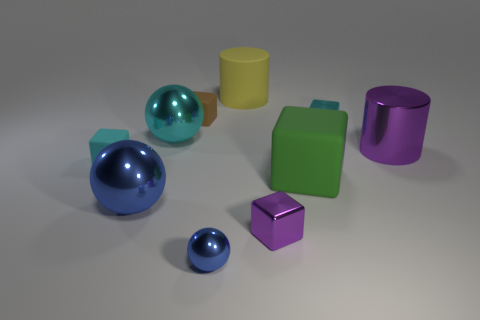Do the shiny cylinder and the metal cube in front of the large green cube have the same color?
Provide a succinct answer. Yes. What number of objects are either objects left of the small purple shiny thing or small blocks left of the tiny sphere?
Your answer should be compact. 6. There is a tiny cube that is to the left of the big green block and behind the metallic cylinder; what color is it?
Provide a short and direct response. Brown. Are there more big matte things than things?
Provide a succinct answer. No. Do the tiny shiny object right of the small purple shiny thing and the large purple metal object have the same shape?
Offer a terse response. No. What number of metallic objects are either tiny purple cubes or big cyan spheres?
Your answer should be very brief. 2. Is there a tiny purple thing made of the same material as the large purple thing?
Ensure brevity in your answer.  Yes. What is the yellow cylinder made of?
Offer a very short reply. Rubber. There is a blue object that is left of the blue metallic thing that is in front of the large ball that is in front of the green matte thing; what shape is it?
Provide a succinct answer. Sphere. Is the number of blue things in front of the tiny purple thing greater than the number of gray matte objects?
Provide a short and direct response. Yes. 